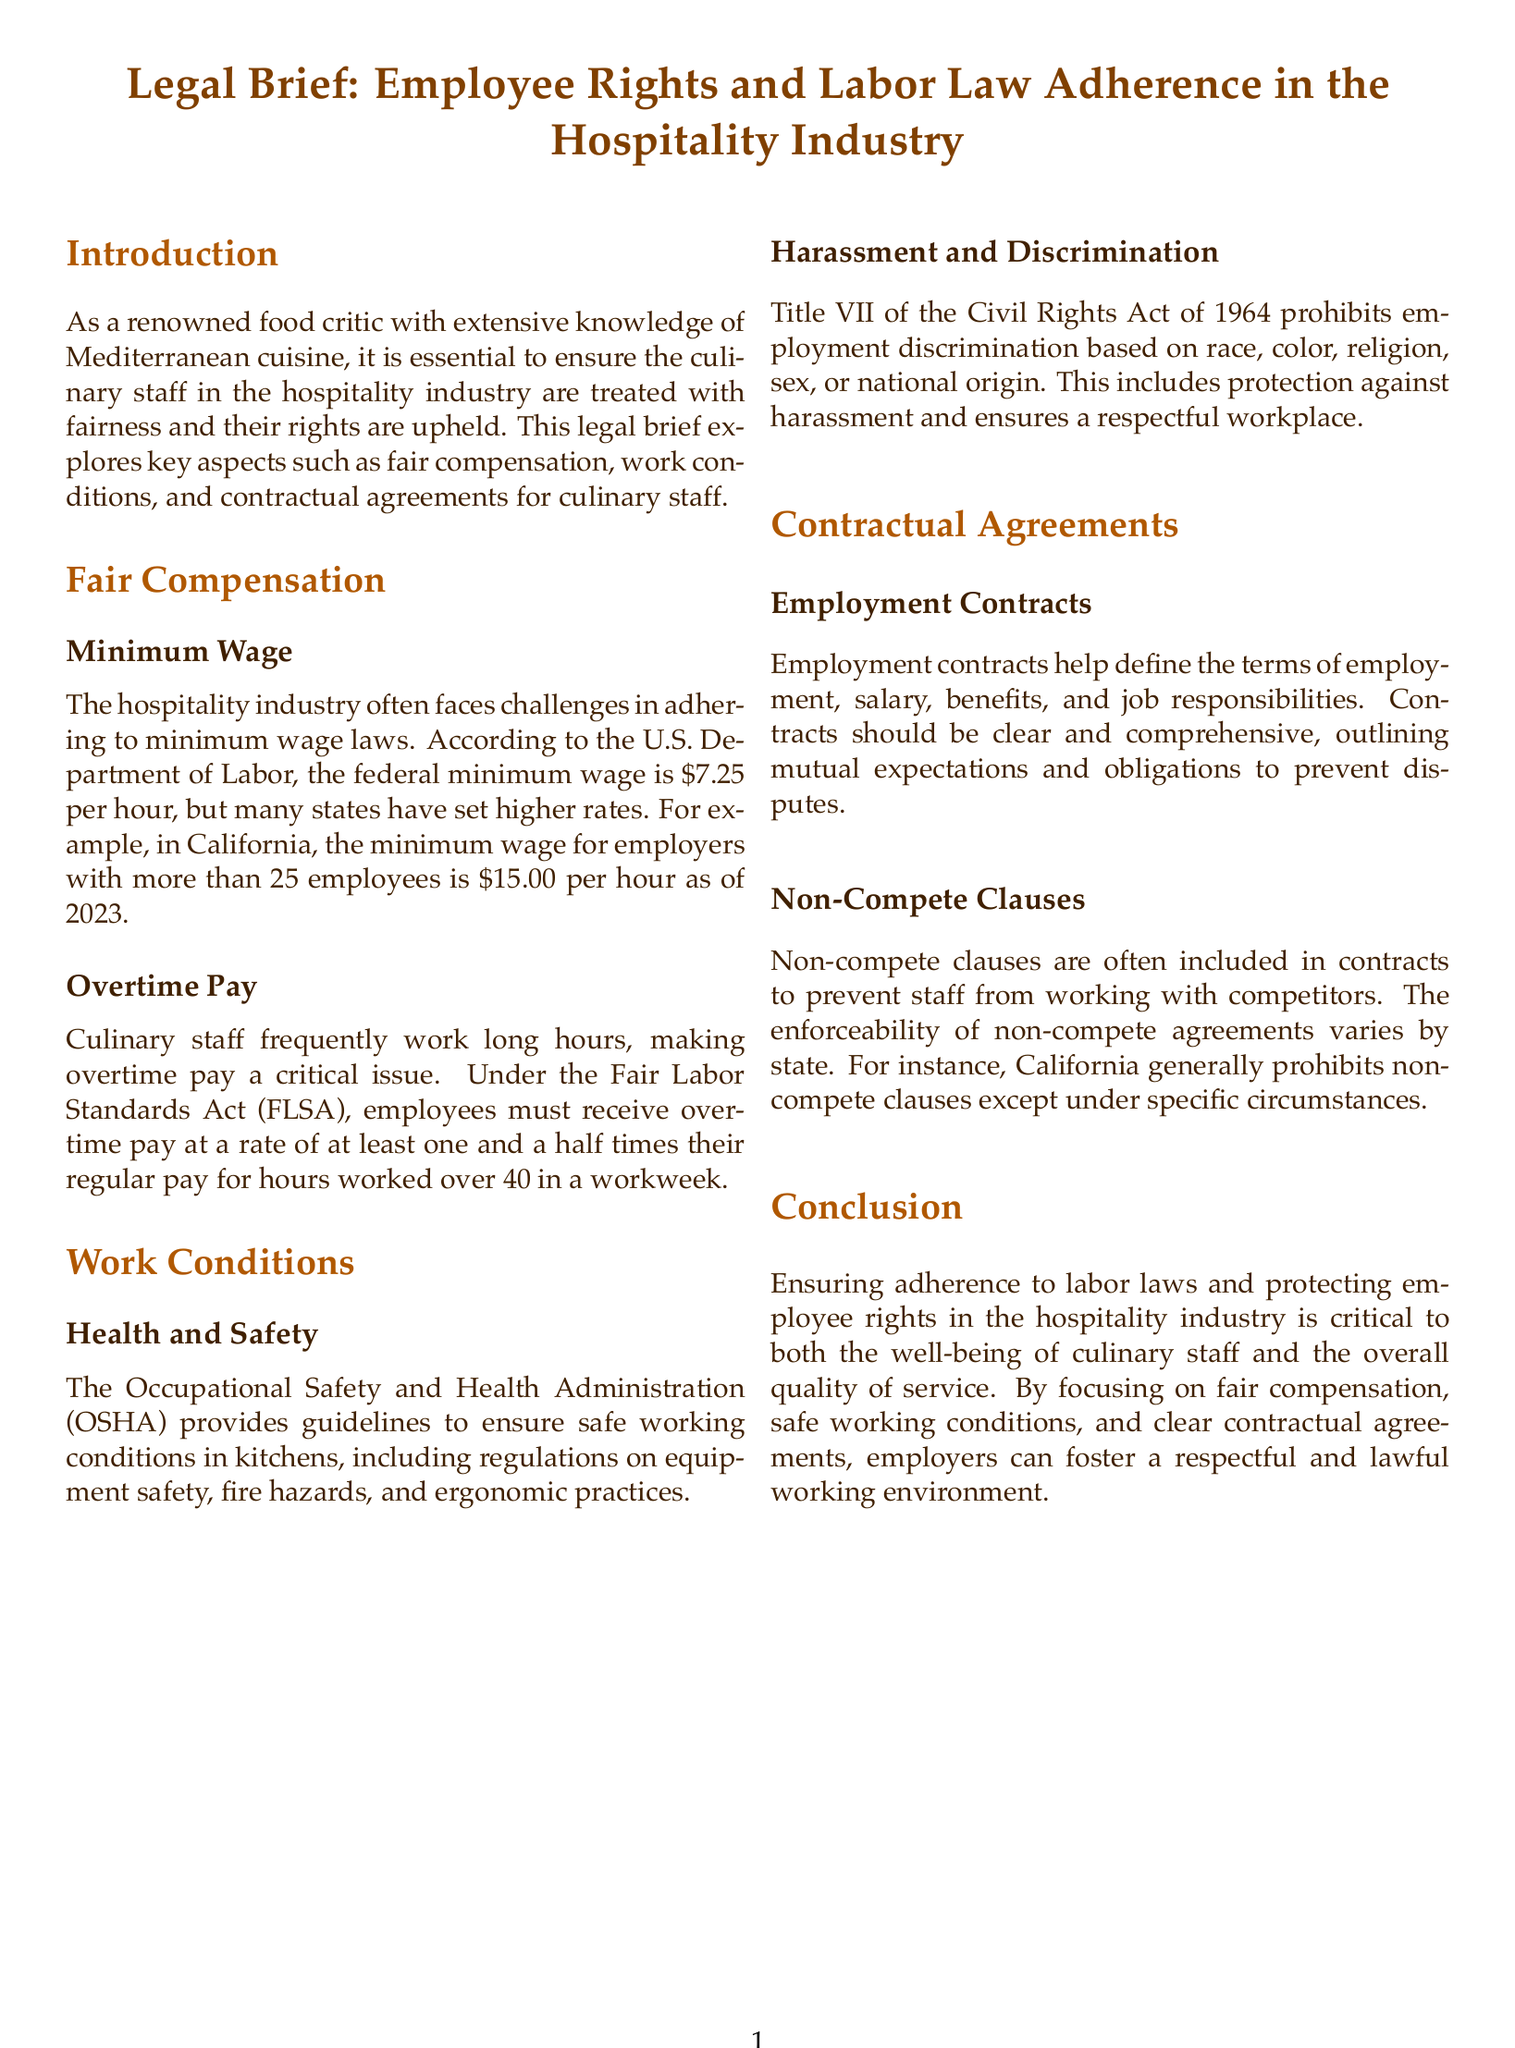What is the federal minimum wage as mentioned in the document? The document states the federal minimum wage is $7.25 per hour.
Answer: $7.25 per hour What is the minimum wage in California for employers with more than 25 employees? According to the document, the minimum wage in California is $15.00 per hour as of 2023.
Answer: $15.00 per hour What is the rate of overtime pay under the Fair Labor Standards Act for hours worked over 40 in a workweek? The document mentions that employees must receive overtime pay at a rate of at least one and a half times their regular pay.
Answer: One and a half times their regular pay Which act prohibits employment discrimination based on race, color, religion, sex, or national origin? Title VII of the Civil Rights Act of 1964 is the act referenced in the document.
Answer: Title VII of the Civil Rights Act of 1964 What does OSHA stand for? The document refers to the Occupational Safety and Health Administration.
Answer: Occupational Safety and Health Administration What should employment contracts outline according to the document? The document states that contracts should outline mutual expectations and obligations to prevent disputes.
Answer: Mutual expectations and obligations What is the primary focus of this legal brief? The legal brief primarily focuses on employee rights and labor law adherence in the hospitality industry.
Answer: Employee rights and labor law adherence What is one key principle advocated in the conclusion? The conclusion emphasizes that ensuring adherence to labor laws is critical for the well-being of culinary staff.
Answer: Adherence to labor laws Are non-compete clauses enforceable in California? The document states that California generally prohibits non-compete clauses except under specific circumstances.
Answer: Generally prohibited except under specific circumstances 